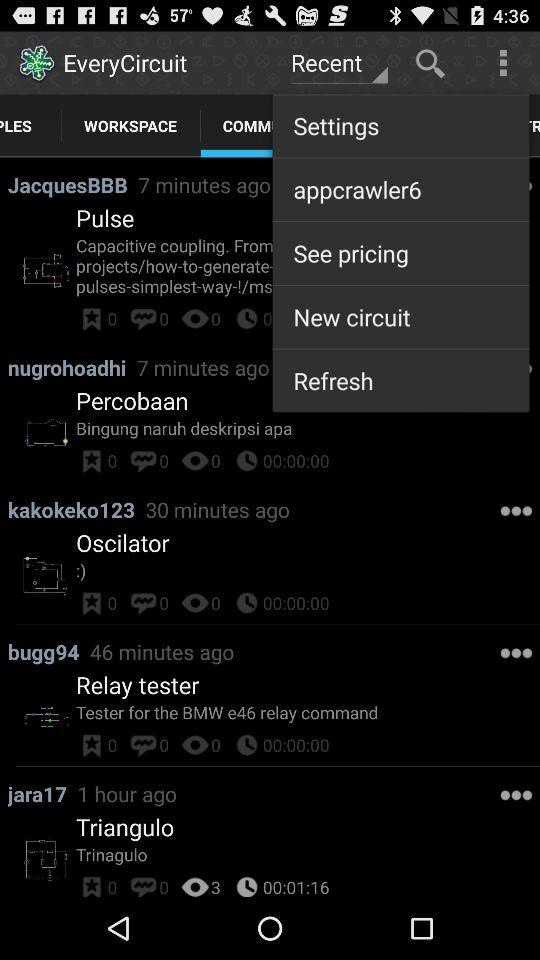What is the application name? The application name is "EveryCircuit". 